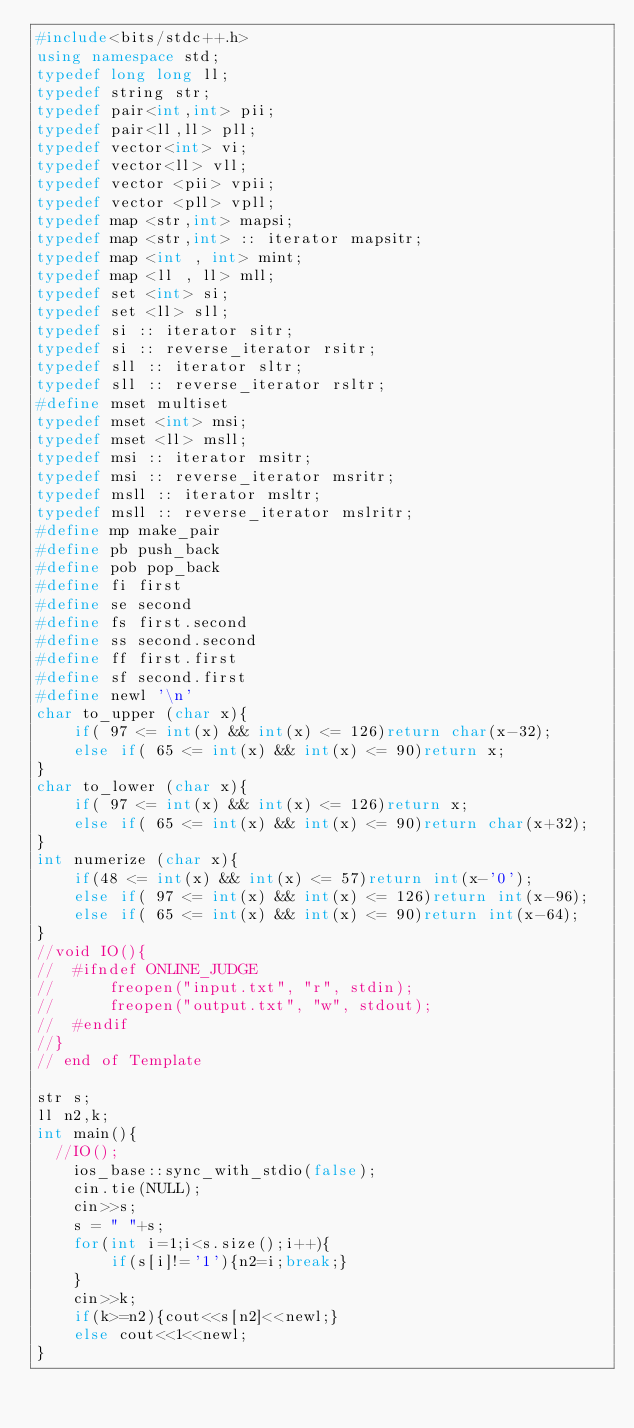<code> <loc_0><loc_0><loc_500><loc_500><_C++_>#include<bits/stdc++.h>
using namespace std;
typedef long long ll;
typedef string str;
typedef pair<int,int> pii;
typedef pair<ll,ll> pll;
typedef vector<int> vi;
typedef vector<ll> vll;
typedef vector <pii> vpii;
typedef vector <pll> vpll;
typedef map <str,int> mapsi;
typedef map <str,int> :: iterator mapsitr;
typedef map <int , int> mint;
typedef map <ll , ll> mll;
typedef set <int> si;
typedef set <ll> sll;
typedef si :: iterator sitr;
typedef si :: reverse_iterator rsitr;
typedef sll :: iterator sltr;
typedef sll :: reverse_iterator rsltr;
#define mset multiset
typedef mset <int> msi;
typedef mset <ll> msll;
typedef msi :: iterator msitr;
typedef msi :: reverse_iterator msritr;
typedef msll :: iterator msltr;
typedef msll :: reverse_iterator mslritr;
#define mp make_pair
#define pb push_back
#define pob pop_back
#define fi first
#define se second
#define fs first.second
#define ss second.second
#define ff first.first
#define sf second.first
#define newl '\n'
char to_upper (char x){
    if( 97 <= int(x) && int(x) <= 126)return char(x-32);
    else if( 65 <= int(x) && int(x) <= 90)return x;
}
char to_lower (char x){
    if( 97 <= int(x) && int(x) <= 126)return x;
    else if( 65 <= int(x) && int(x) <= 90)return char(x+32);
}
int numerize (char x){
    if(48 <= int(x) && int(x) <= 57)return int(x-'0');
    else if( 97 <= int(x) && int(x) <= 126)return int(x-96);
    else if( 65 <= int(x) && int(x) <= 90)return int(x-64);
}
//void IO(){
//	#ifndef ONLINE_JUDGE
//	    freopen("input.txt", "r", stdin);
//	    freopen("output.txt", "w", stdout);
//	#endif
//}
// end of Template

str s;
ll n2,k;
int main(){
	//IO();
    ios_base::sync_with_stdio(false);
    cin.tie(NULL);
    cin>>s;
    s = " "+s;
    for(int i=1;i<s.size();i++){
        if(s[i]!='1'){n2=i;break;}
    }
    cin>>k;
    if(k>=n2){cout<<s[n2]<<newl;}
    else cout<<1<<newl;
}
</code> 